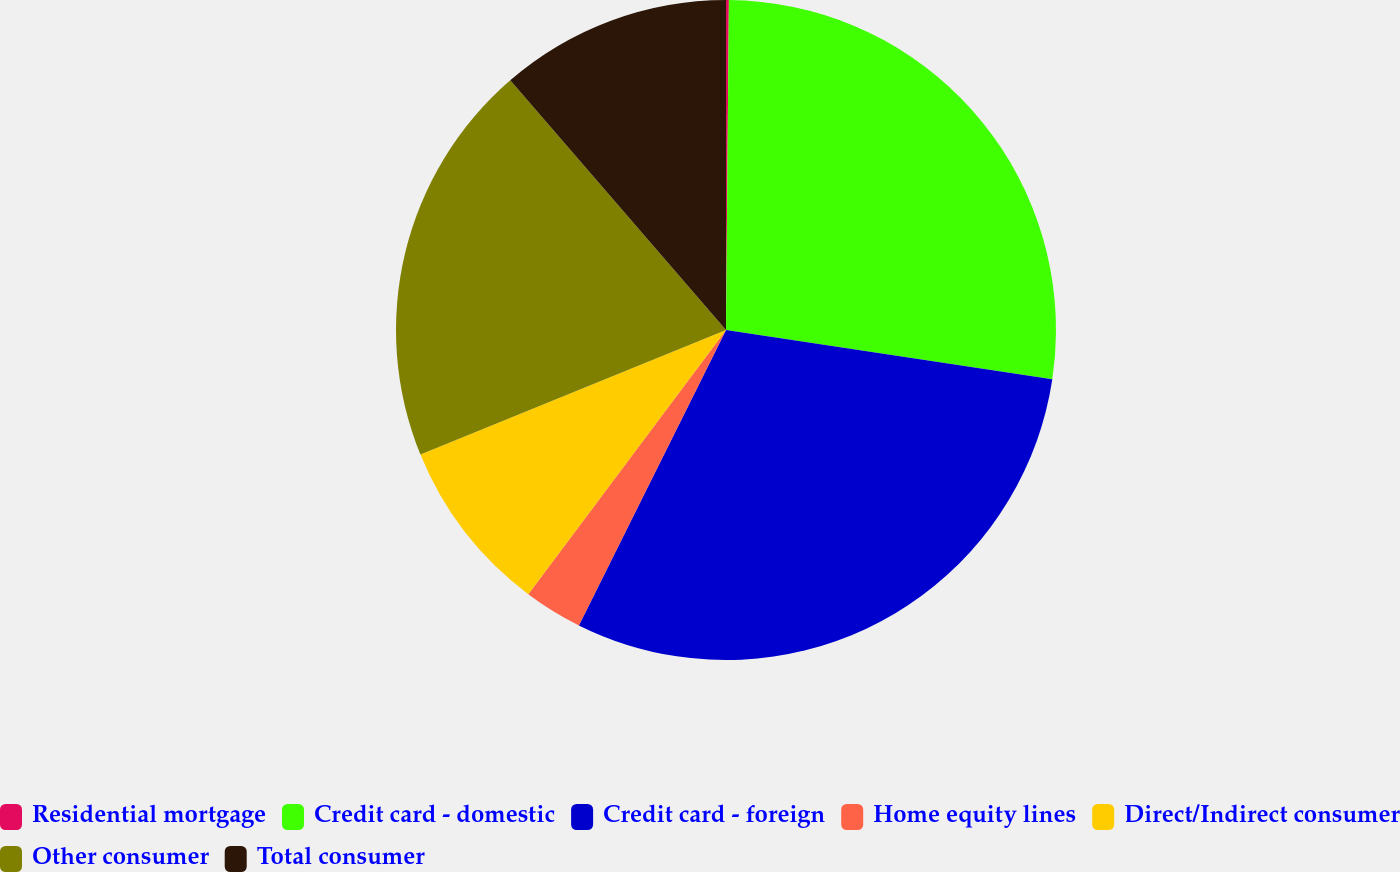Convert chart. <chart><loc_0><loc_0><loc_500><loc_500><pie_chart><fcel>Residential mortgage<fcel>Credit card - domestic<fcel>Credit card - foreign<fcel>Home equity lines<fcel>Direct/Indirect consumer<fcel>Other consumer<fcel>Total consumer<nl><fcel>0.14%<fcel>27.24%<fcel>29.97%<fcel>2.87%<fcel>8.61%<fcel>19.82%<fcel>11.34%<nl></chart> 